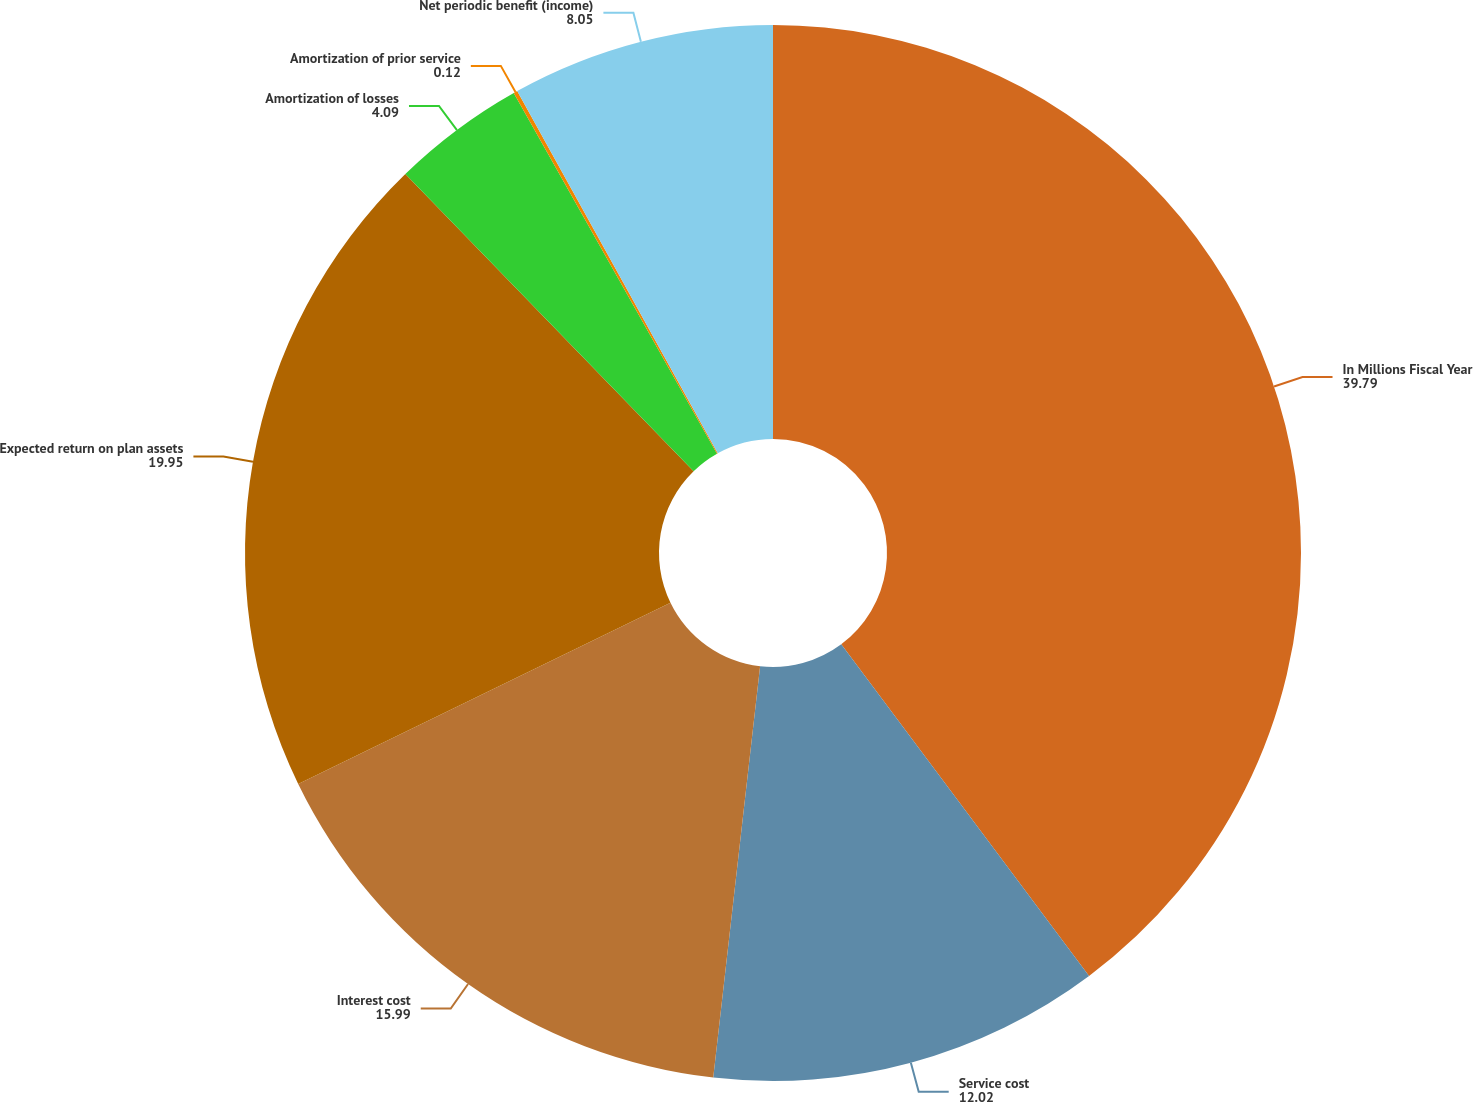Convert chart. <chart><loc_0><loc_0><loc_500><loc_500><pie_chart><fcel>In Millions Fiscal Year<fcel>Service cost<fcel>Interest cost<fcel>Expected return on plan assets<fcel>Amortization of losses<fcel>Amortization of prior service<fcel>Net periodic benefit (income)<nl><fcel>39.79%<fcel>12.02%<fcel>15.99%<fcel>19.95%<fcel>4.09%<fcel>0.12%<fcel>8.05%<nl></chart> 